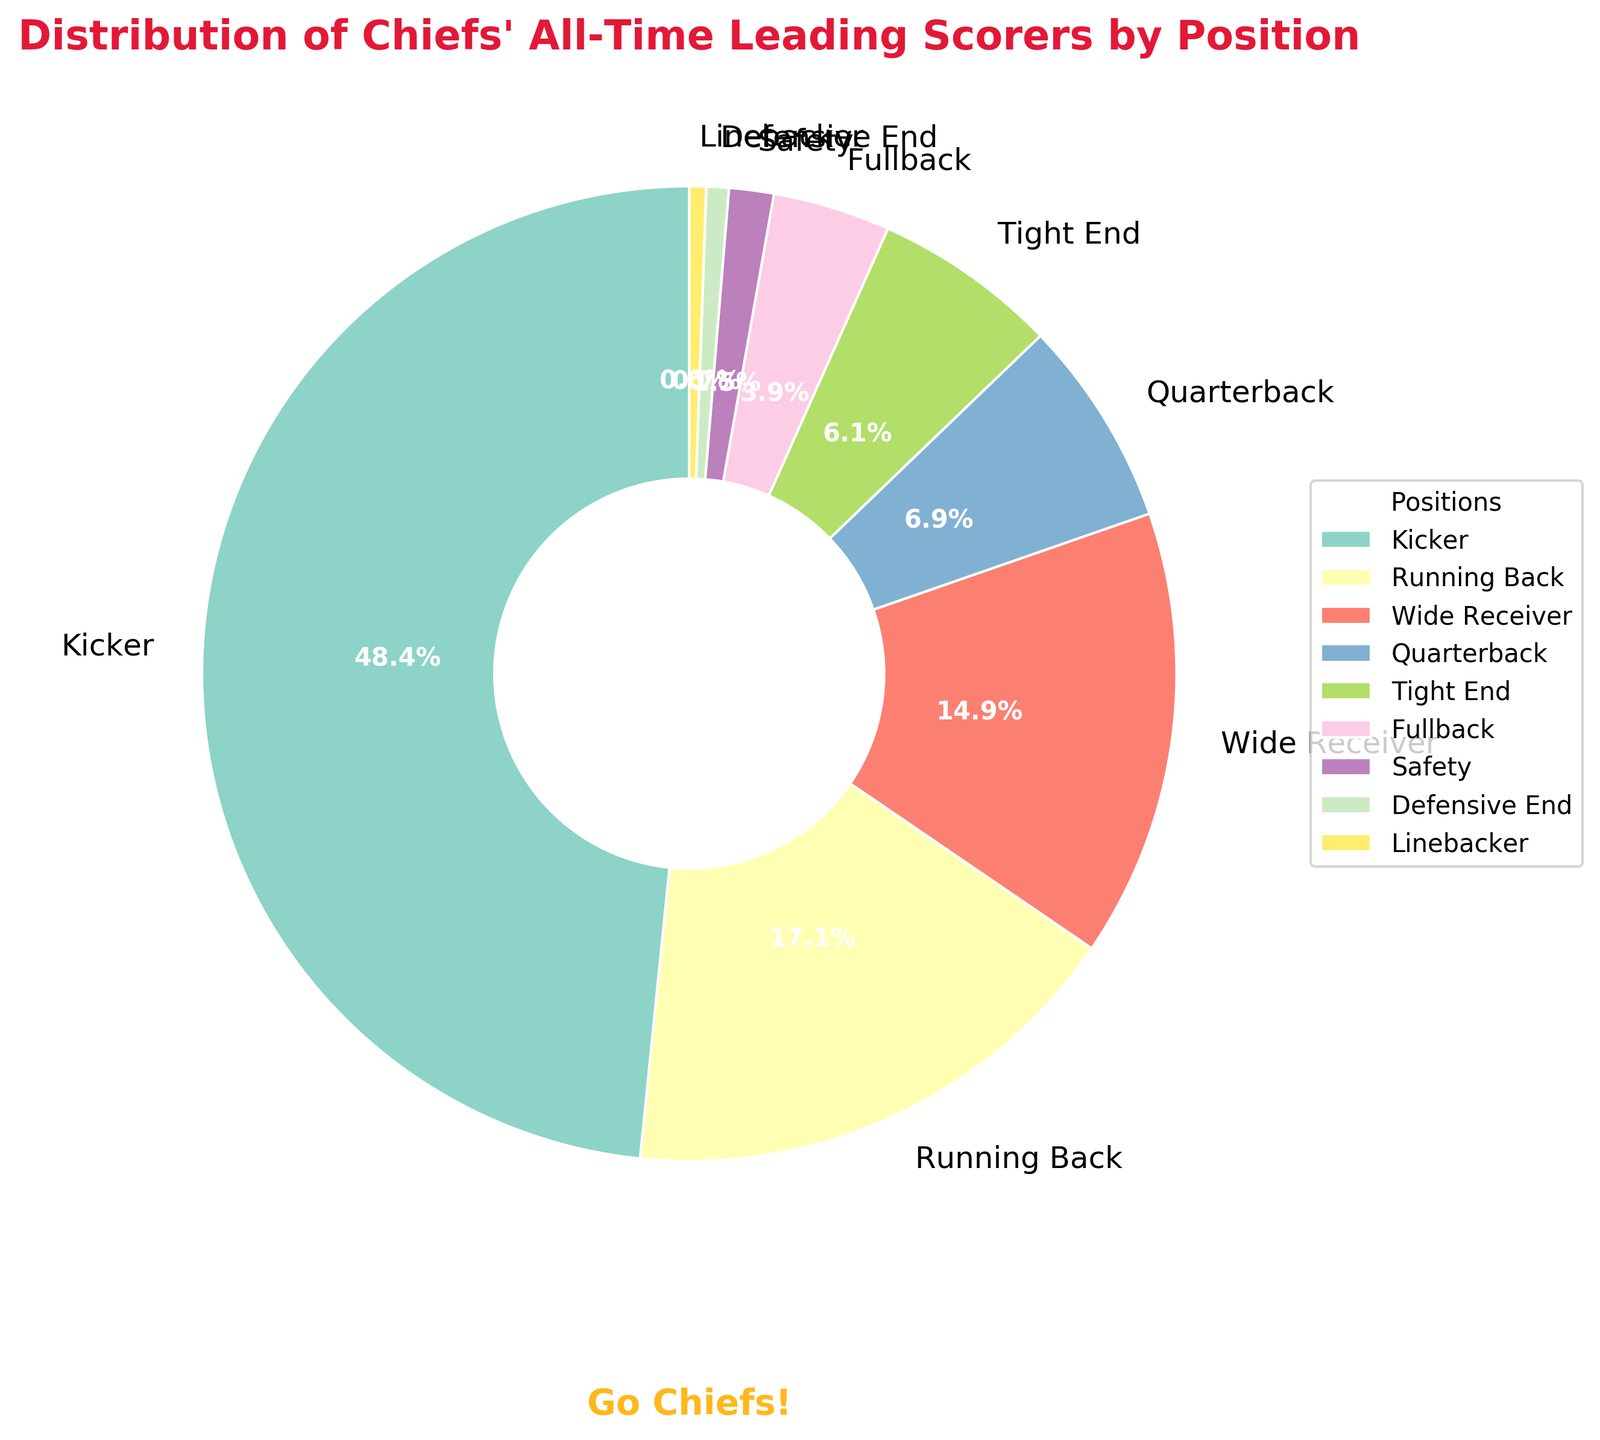Which position has the highest number of points? The pie chart displays the distribution by position. The Kicker section is the largest, indicating the highest number of points.
Answer: Kicker What percentage of points does the Running Back position account for? To find the percentage, refer to the labeled pie chart segment for Running Back. It shows 552 points, which is 17.5% of the total.
Answer: 17.5% How much more points does the Kicker have compared to the Wide Receiver? Subtract the points of the Wide Receiver (480) from the points of the Kicker (1564). The difference is 1564 - 480 = 1084 points.
Answer: 1084 Which position has the least number of points? The smallest segment on the pie chart represents the position with the fewest points. This is the Linebacker position with 18 points.
Answer: Linebacker How do the combined points of Quarterback and Running Back compare to the Kicker? Sum the points of Quarterback (222) and Running Back (552): 222 + 552 = 774. Then compare this to the Kicker's 1564 points. 774 is less than 1564.
Answer: Less than Are the points for the Tight End position greater than those for the Quarterback? Compare the points directly: Tight End has 198 points, while Quarterback has 222 points. So, Tight End has fewer points.
Answer: No What percentage of points do the positions other than Kicker account for? First sum the points of all positions other than Kicker: 552 + 480 + 222 + 198 + 126 + 48 + 24 + 18 = 1668. The total points are 1564 (Kicker) + 1668 = 3232. Calculate the percentage: (1668 / 3232) * 100 ≈ 51.6%.
Answer: 51.6% How many positions have points greater than 100? Identify each segment above 100 points: Kicker (1564), Running Back (552), Wide Receiver (480), Quarterback (222), and Tight End (198). Fullback with 126 points is also above 100. There are 6 such positions.
Answer: 6 What is the combined percentage of points from the Tight End and Fullback positions? Add the points of Tight End (198) and Fullback (126): 198 + 126 = 324. Then, calculate the percentage: (324 / 3232) * 100 ≈ 10.0%.
Answer: 10.0% In comparison to the Linebacker, how many times more points does the Safety have? Safety has 48 points and Linebacker has 18 points. Calculate how many times more: 48 / 18 ≈ 2.67 times.
Answer: 2.67 times 